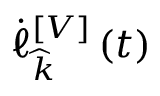Convert formula to latex. <formula><loc_0><loc_0><loc_500><loc_500>\dot { \ell } _ { \widehat { k } } ^ { \left [ V \right ] } \left ( t \right )</formula> 